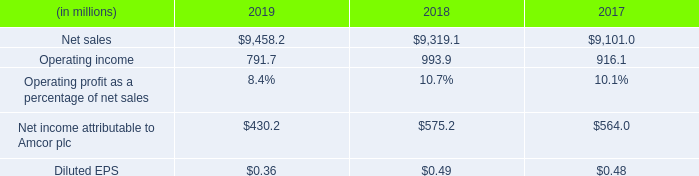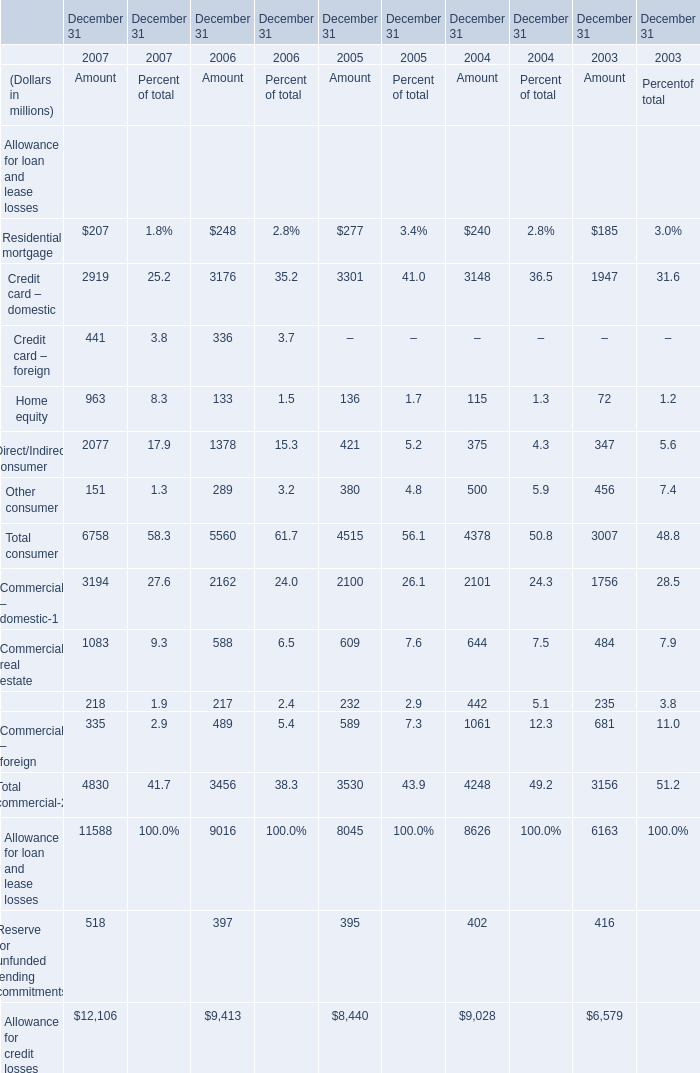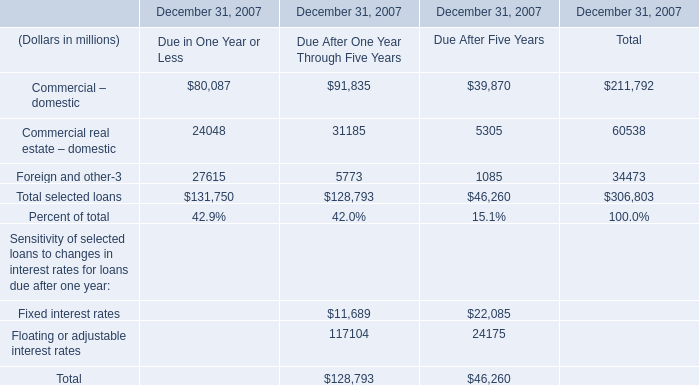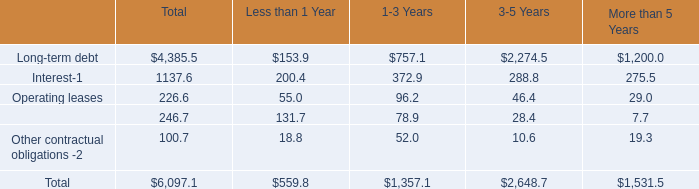What is the average value of Total consumer for Amount and Total selected loans for Due in One Year or Less in 2007? (in million) 
Computations: ((6758 + 131750) / 2)
Answer: 69254.0. 